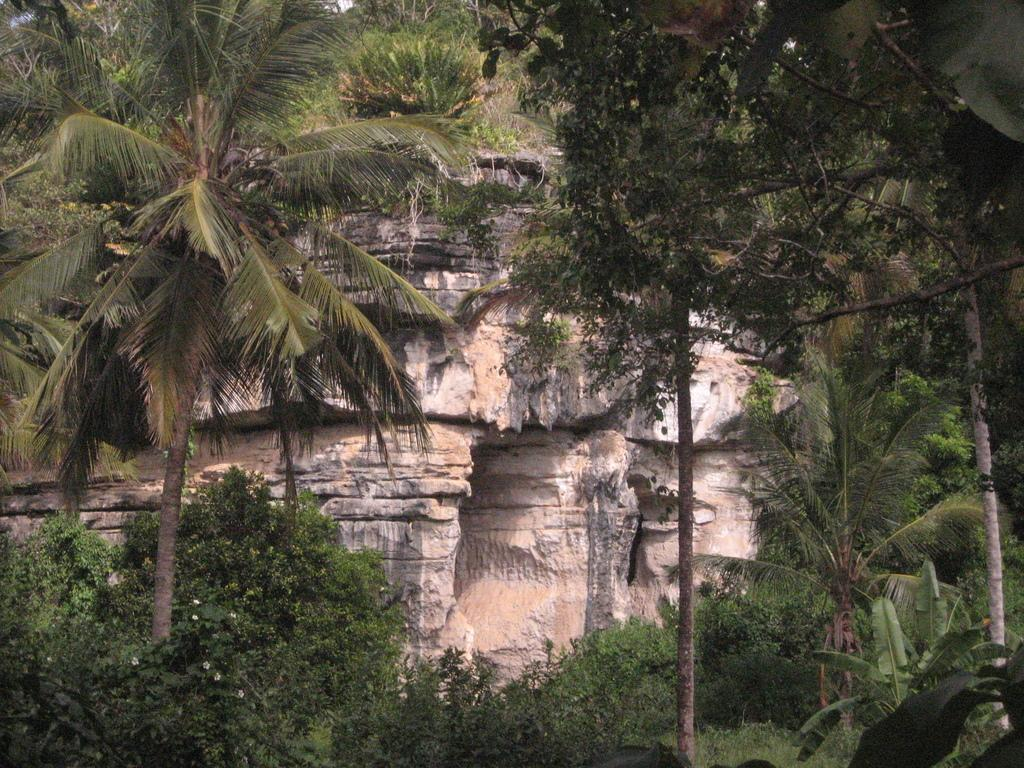What natural formation can be seen in the image? The Amboni caves are visible in the image. What type of vegetation is present in the image? There are plants with flowers, trees, bushes, and grass visible in the image. Can you describe the plants in the image? Plants are visible in the image, including those with flowers. What type of pain can be seen on the faces of the snails in the image? There are no snails present in the image, so it is not possible to determine if they are experiencing any pain. How many cherries are visible on the trees in the image? There are no cherries present in the image; the trees are not bearing fruit. 